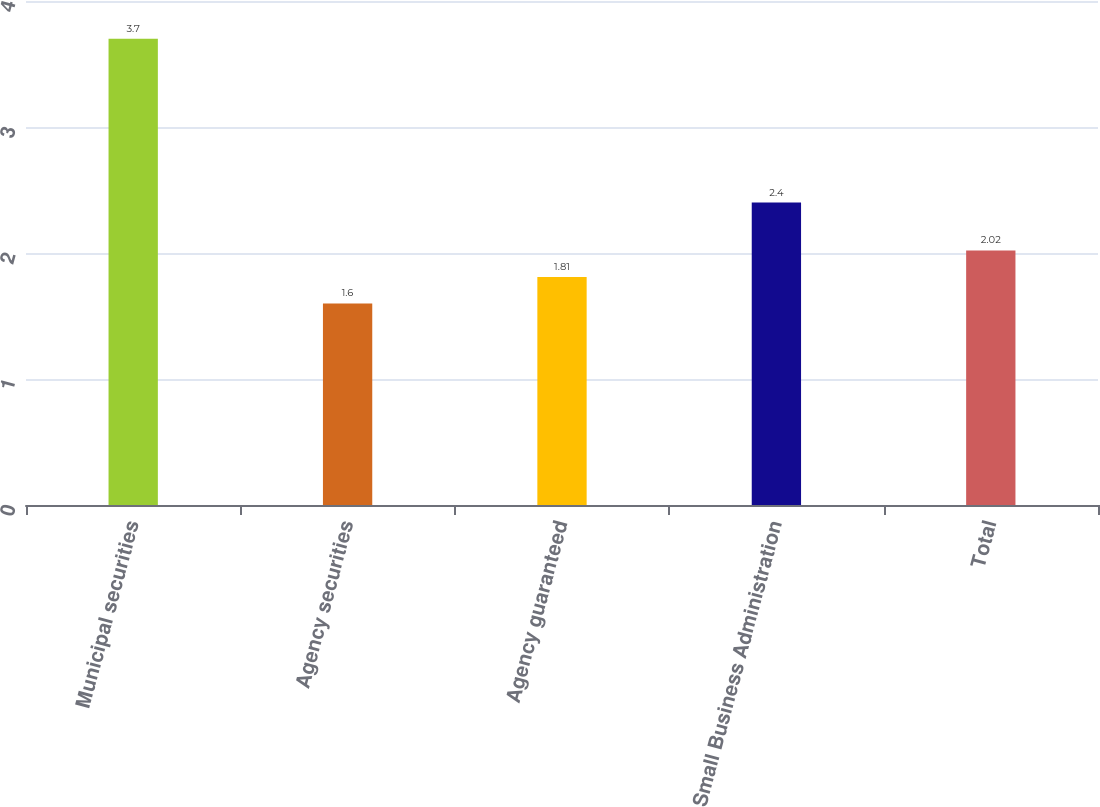<chart> <loc_0><loc_0><loc_500><loc_500><bar_chart><fcel>Municipal securities<fcel>Agency securities<fcel>Agency guaranteed<fcel>Small Business Administration<fcel>Total<nl><fcel>3.7<fcel>1.6<fcel>1.81<fcel>2.4<fcel>2.02<nl></chart> 